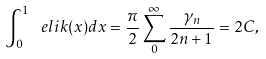Convert formula to latex. <formula><loc_0><loc_0><loc_500><loc_500>\int _ { 0 } ^ { 1 } { \ e l i k ( x ) d x } = \frac { \pi } { 2 } \sum _ { 0 } ^ { \infty } { \frac { \gamma _ { n } } { 2 n + 1 } } = 2 C ,</formula> 